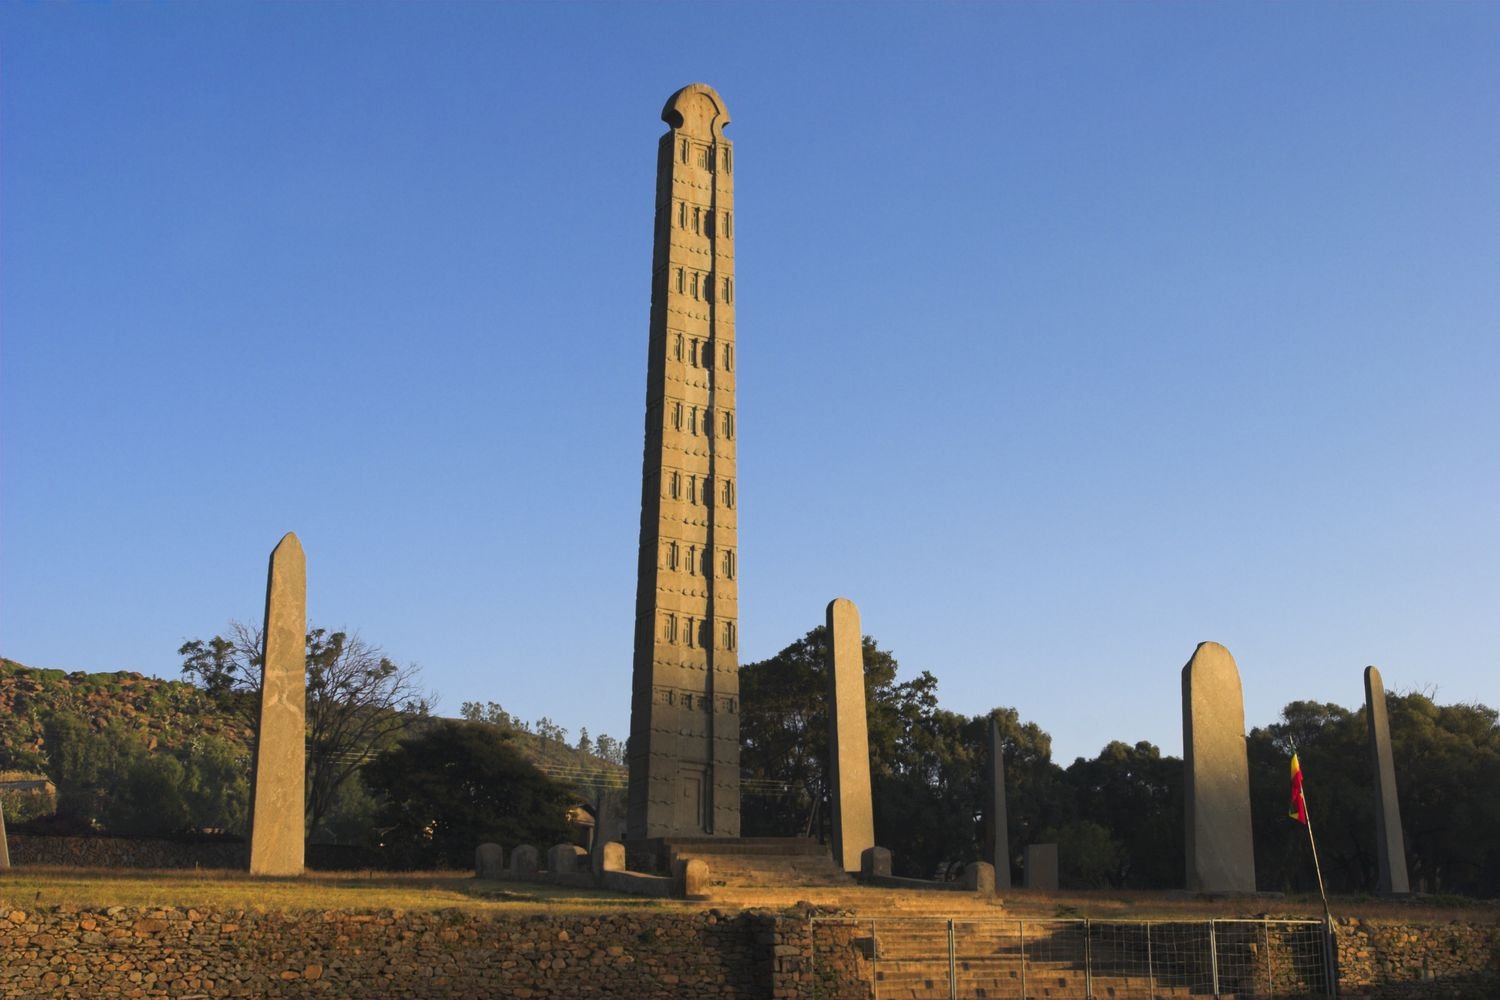If this site could speak, what stories would it tell? If the Obelisk of Axum could speak, it would tell tales of a mighty empire, the Kingdom of Aksum, which thrived from the 1st to the 7th century AD. It would recount the grandeur of emperors and the rich cultural exchanges due to its strategic position along trade routes connecting the Roman Empire and India. The obelisk would share stories of ceremonial gatherings, royal burials, and the spread of Christianity in ancient Ethiopia. It would whisper about the labor and craftsmanship that went into carving and erecting such a marvel from a single piece of granite, and it would echo the sounds of ancient prayers and rituals conducted in its shadow. Describe the environmental setting and its impact on the monument. The Obelisk of Axum is situated in a lush environment with green trees and a mountainous backdrop, under a typically clear blue Ethiopian sky. This natural setting not only enhances the visual splendor of the monument but also plays a role in its preservation and ambiance. The granite used in the obelisk has endured centuries of weather changes, standing resilient against the elements. The serene and picturesque environment enriches the historical aura of the site, making it a harmonious blend of nature and human achievement, reflective of how the Aksumites lived in accord with their natural surroundings. 